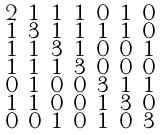Convert formula to latex. <formula><loc_0><loc_0><loc_500><loc_500>\begin{smallmatrix} 2 & 1 & 1 & 1 & 0 & 1 & 0 \\ 1 & 3 & 1 & 1 & 1 & 1 & 0 \\ 1 & 1 & 3 & 1 & 0 & 0 & 1 \\ 1 & 1 & 1 & 3 & 0 & 0 & 0 \\ 0 & 1 & 0 & 0 & 3 & 1 & 1 \\ 1 & 1 & 0 & 0 & 1 & 3 & 0 \\ 0 & 0 & 1 & 0 & 1 & 0 & 3 \end{smallmatrix}</formula> 